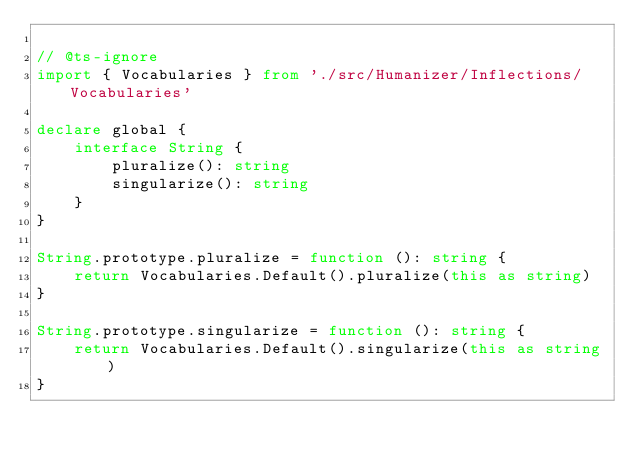<code> <loc_0><loc_0><loc_500><loc_500><_TypeScript_>
// @ts-ignore
import { Vocabularies } from './src/Humanizer/Inflections/Vocabularies'

declare global {
    interface String {
        pluralize(): string
        singularize(): string
    }
}

String.prototype.pluralize = function (): string {
    return Vocabularies.Default().pluralize(this as string)
}

String.prototype.singularize = function (): string {
    return Vocabularies.Default().singularize(this as string)
}


</code> 